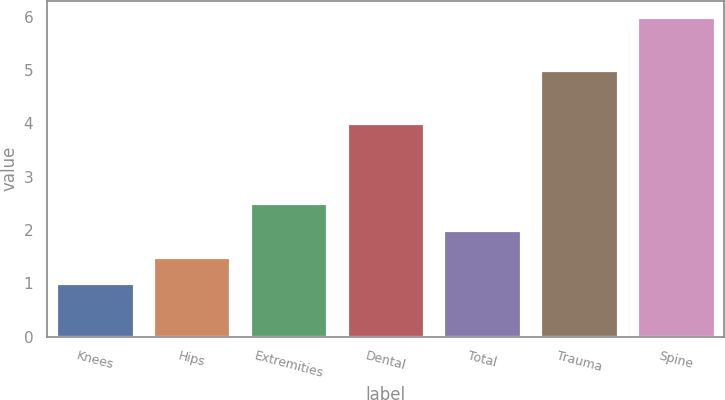Convert chart to OTSL. <chart><loc_0><loc_0><loc_500><loc_500><bar_chart><fcel>Knees<fcel>Hips<fcel>Extremities<fcel>Dental<fcel>Total<fcel>Trauma<fcel>Spine<nl><fcel>1<fcel>1.5<fcel>2.5<fcel>4<fcel>2<fcel>5<fcel>6<nl></chart> 